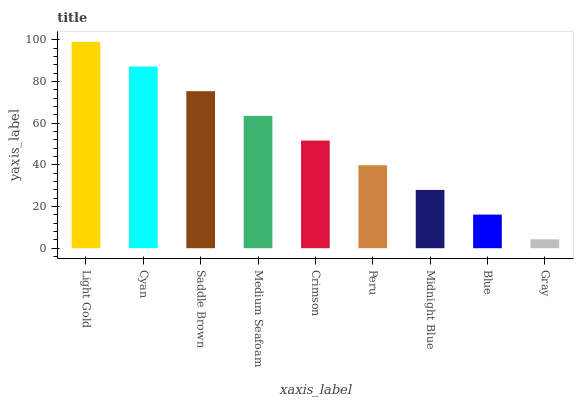Is Cyan the minimum?
Answer yes or no. No. Is Cyan the maximum?
Answer yes or no. No. Is Light Gold greater than Cyan?
Answer yes or no. Yes. Is Cyan less than Light Gold?
Answer yes or no. Yes. Is Cyan greater than Light Gold?
Answer yes or no. No. Is Light Gold less than Cyan?
Answer yes or no. No. Is Crimson the high median?
Answer yes or no. Yes. Is Crimson the low median?
Answer yes or no. Yes. Is Medium Seafoam the high median?
Answer yes or no. No. Is Peru the low median?
Answer yes or no. No. 